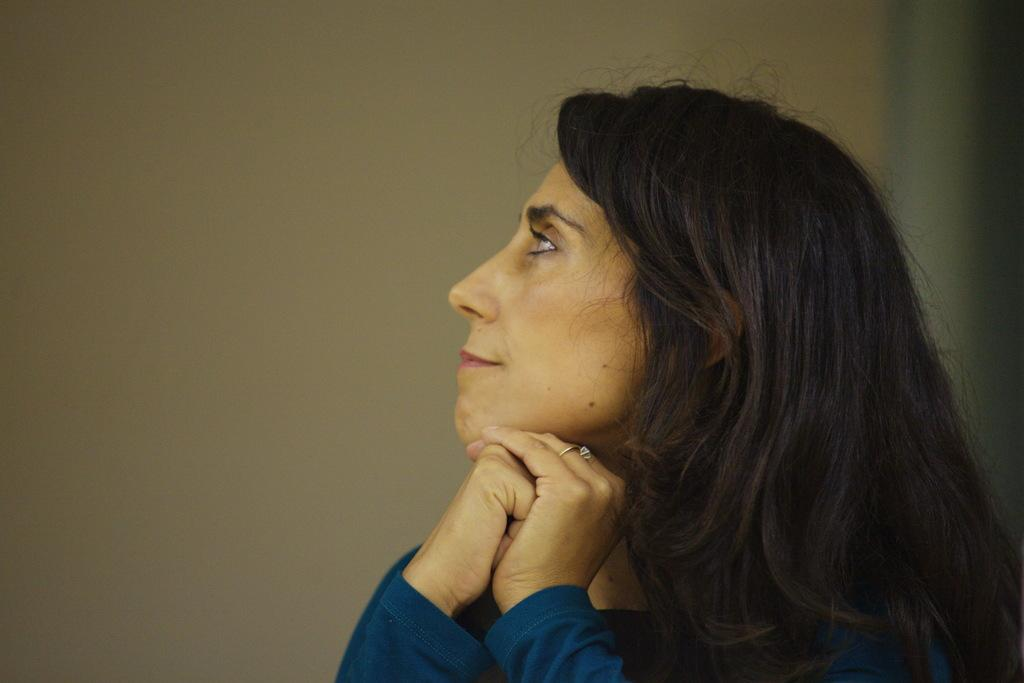What is the main subject in the foreground of the picture? There is a woman in the foreground of the picture. What can be seen in the background of the picture? There is a wall in the background of the picture. What type of pickle is the woman holding in the picture? There is no pickle present in the picture; the woman is not holding anything. What type of creature is visible on the wall in the background? There is no creature visible on the wall in the background; only the wall is present. 